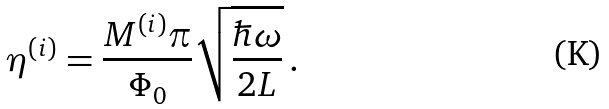Convert formula to latex. <formula><loc_0><loc_0><loc_500><loc_500>\eta ^ { ( i ) } = \frac { M ^ { ( i ) } \pi } { \Phi _ { 0 } } \sqrt { \frac { \hbar { \omega } } { 2 L } } \, .</formula> 